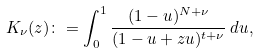Convert formula to latex. <formula><loc_0><loc_0><loc_500><loc_500>K _ { \nu } ( z ) \colon = \int _ { 0 } ^ { 1 } \frac { ( 1 - u ) ^ { N + \nu } } { ( 1 - u + z u ) ^ { t + \nu } } \, d u ,</formula> 